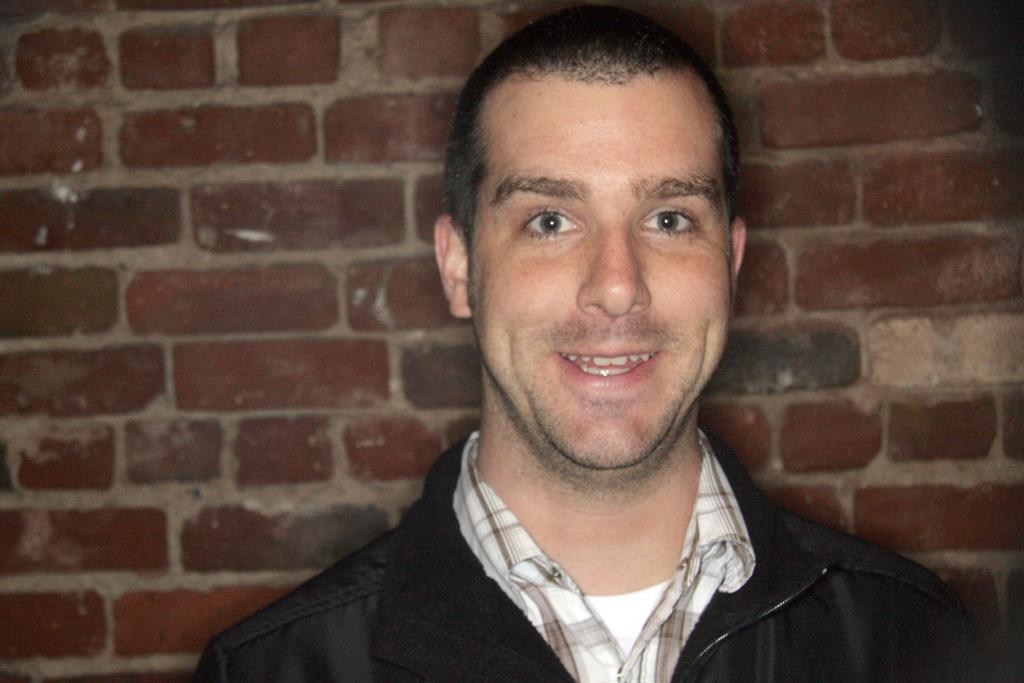Who is present in the image? There is a man in the image. What is the man doing in the image? The man is smiling in the image. What can be seen in the background of the image? There is a brick wall in the background of the image. How does the man adjust the shop in the image? There is no shop present in the image, so the man cannot make any adjustments to it. 